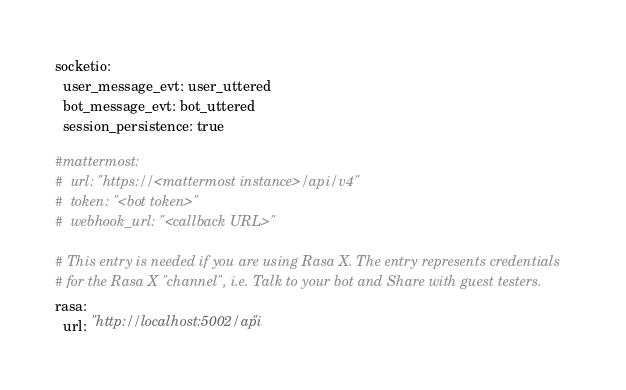<code> <loc_0><loc_0><loc_500><loc_500><_YAML_>
socketio:
  user_message_evt: user_uttered
  bot_message_evt: bot_uttered
  session_persistence: true

#mattermost:
#  url: "https://<mattermost instance>/api/v4"
#  token: "<bot token>"
#  webhook_url: "<callback URL>"

# This entry is needed if you are using Rasa X. The entry represents credentials
# for the Rasa X "channel", i.e. Talk to your bot and Share with guest testers.
rasa:
  url: "http://localhost:5002/api"
</code> 